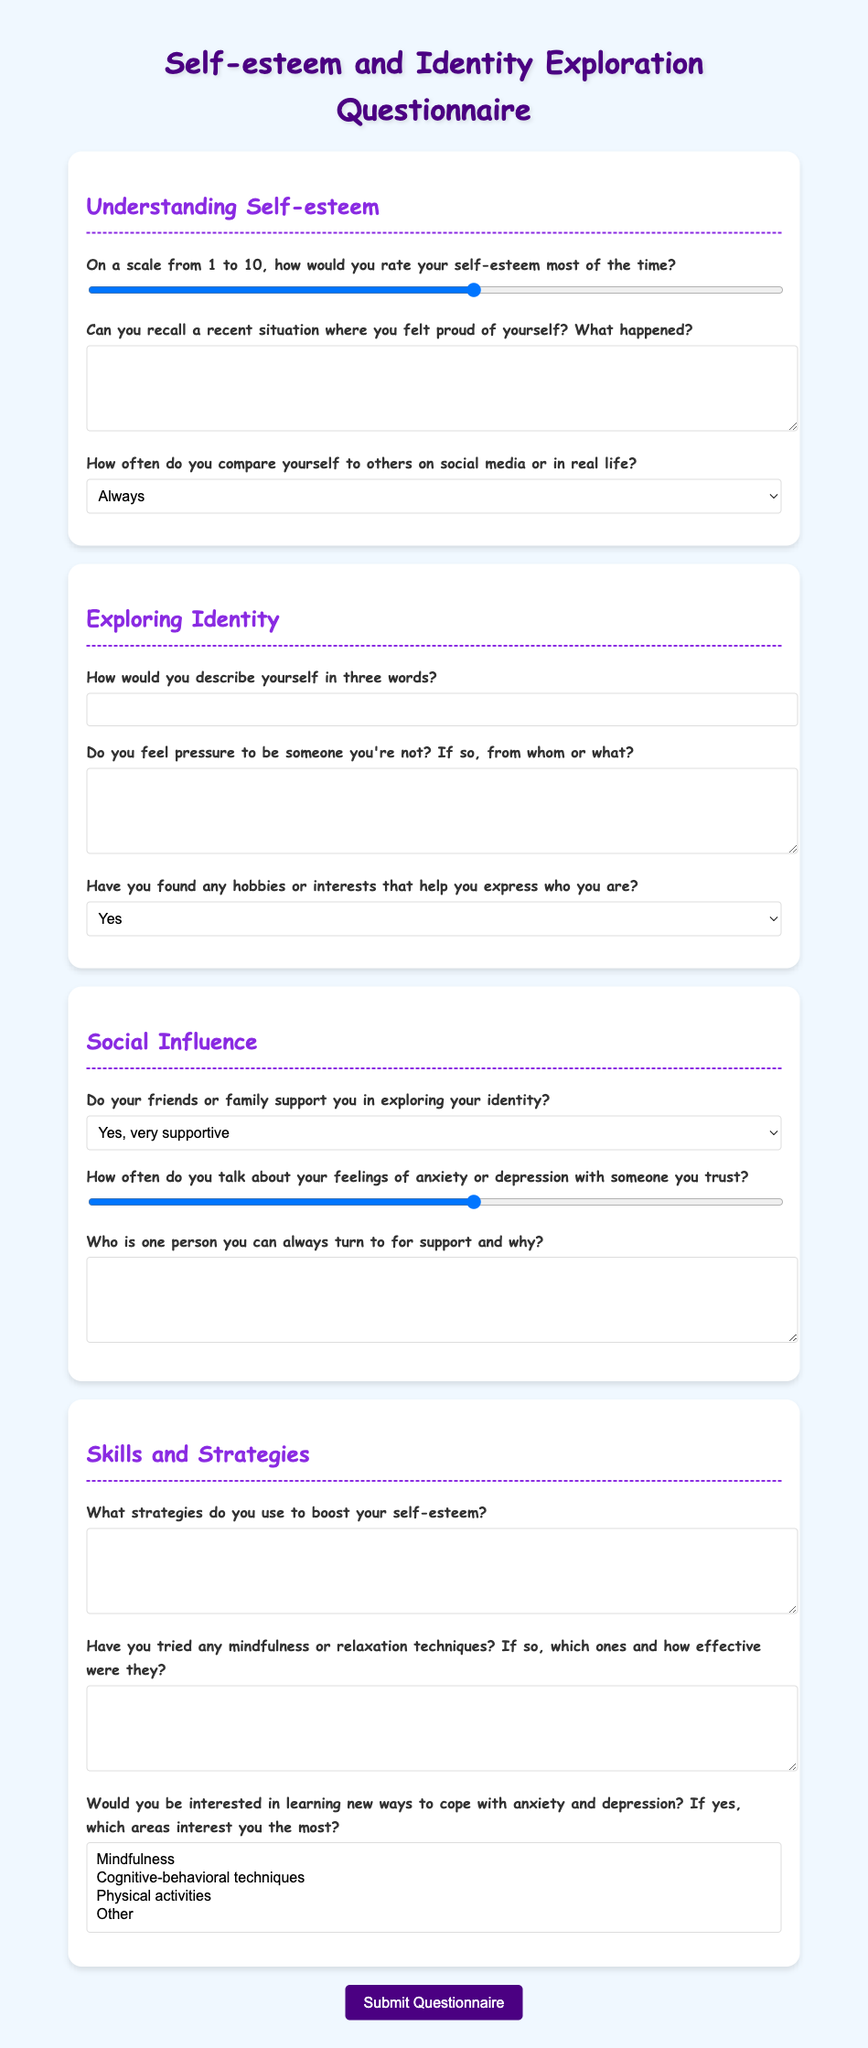What is the title of the document? The title of the document appears at the top of the form and is "Self-esteem and Identity Exploration Questionnaire."
Answer: Self-esteem and Identity Exploration Questionnaire How many sections are there in the questionnaire? The document has four main sections: Understanding Self-esteem, Exploring Identity, Social Influence, and Skills and Strategies.
Answer: Four What scale is used to rate self-esteem? The questionnaire asks respondents to rate their self-esteem on a scale from 1 to 10.
Answer: 1 to 10 What is one question related to exploring identity? The document asks, "How would you describe yourself in three words?" under the Exploring Identity section.
Answer: How would you describe yourself in three words? How often do respondents discuss their feelings with someone they trust? The document provides a range from 1 to 10 for respondents to specify how often they talk about their feelings of anxiety or depression.
Answer: 1 to 10 